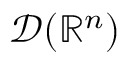Convert formula to latex. <formula><loc_0><loc_0><loc_500><loc_500>{ \mathcal { D } } ( \mathbb { R } ^ { n } )</formula> 